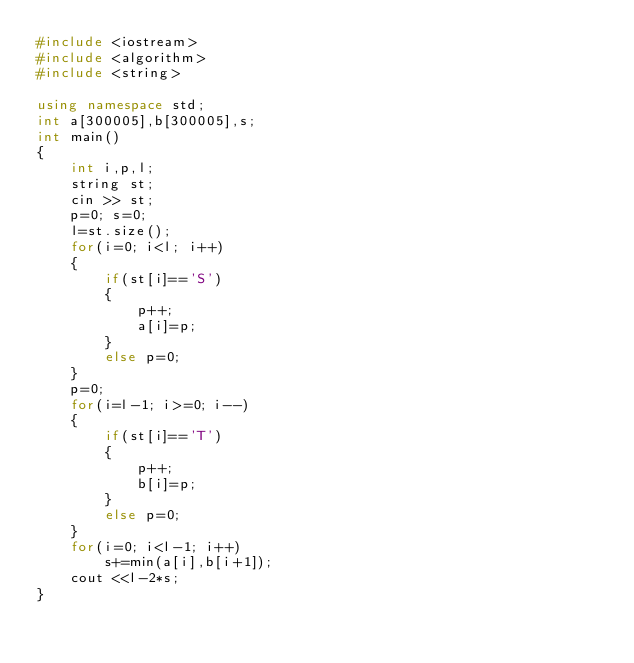Convert code to text. <code><loc_0><loc_0><loc_500><loc_500><_C++_>#include <iostream>
#include <algorithm>
#include <string>

using namespace std;
int a[300005],b[300005],s;
int main()
{
	int i,p,l;
	string st;
	cin >> st;
	p=0; s=0;
	l=st.size();
	for(i=0; i<l; i++)
	{
		if(st[i]=='S') 
		{
			p++;
			a[i]=p;
		}
		else p=0;
	}
	p=0;
	for(i=l-1; i>=0; i--)
	{
		if(st[i]=='T') 
		{
			p++;
			b[i]=p;
		}
		else p=0;
	}
	for(i=0; i<l-1; i++)
		s+=min(a[i],b[i+1]);
	cout <<l-2*s;
}
</code> 